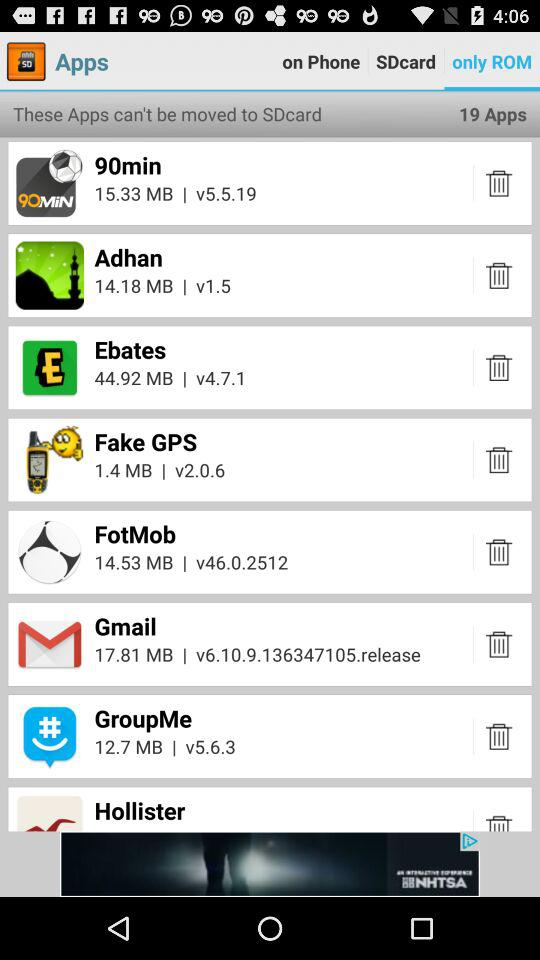Which tab is selected? The selected tab is "only ROM". 